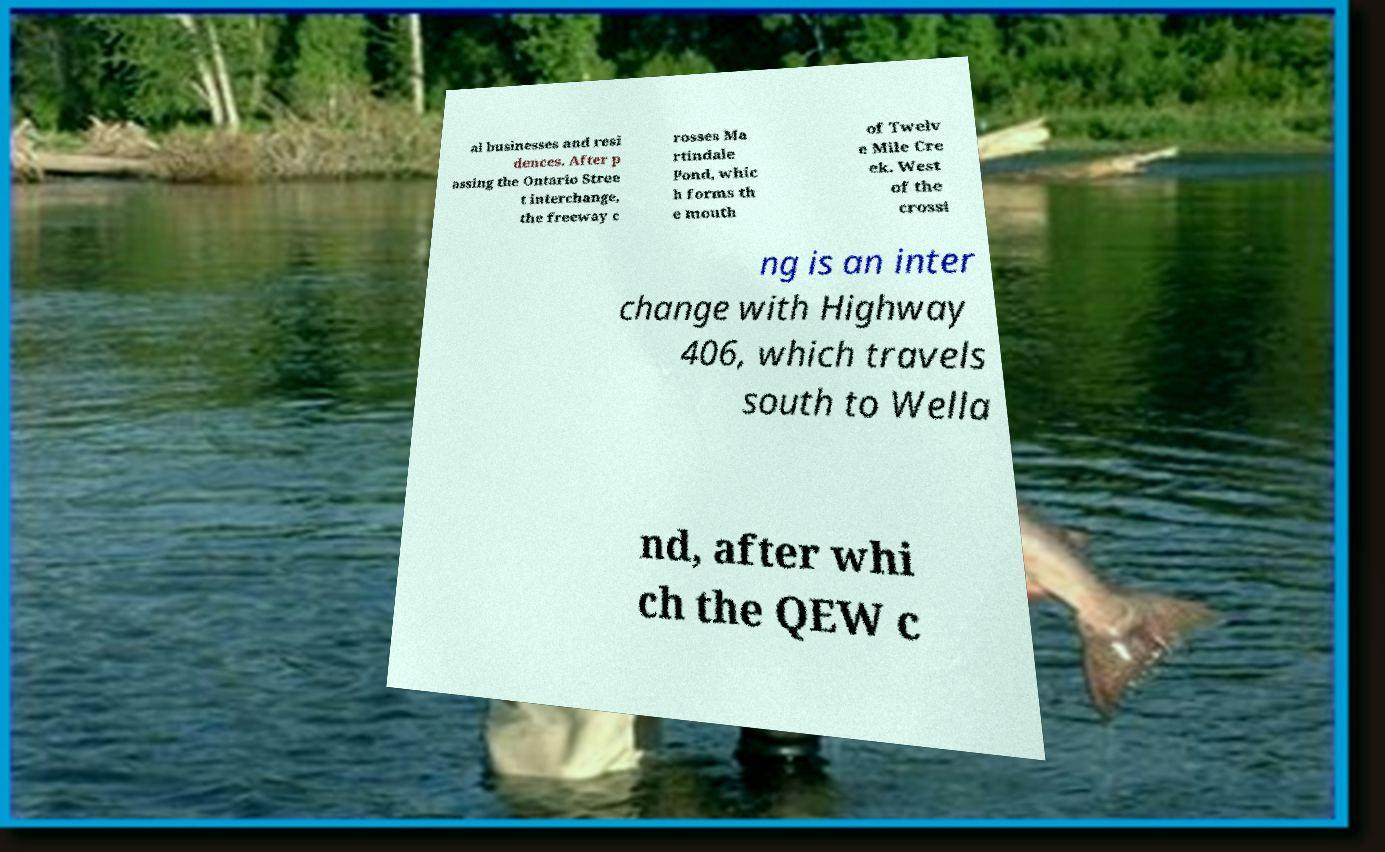What messages or text are displayed in this image? I need them in a readable, typed format. al businesses and resi dences. After p assing the Ontario Stree t interchange, the freeway c rosses Ma rtindale Pond, whic h forms th e mouth of Twelv e Mile Cre ek. West of the crossi ng is an inter change with Highway 406, which travels south to Wella nd, after whi ch the QEW c 